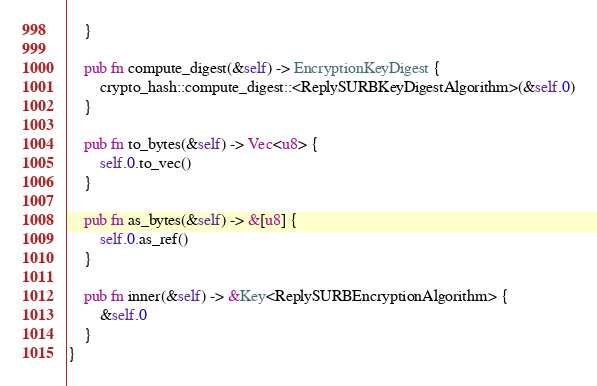Convert code to text. <code><loc_0><loc_0><loc_500><loc_500><_Rust_>    }

    pub fn compute_digest(&self) -> EncryptionKeyDigest {
        crypto_hash::compute_digest::<ReplySURBKeyDigestAlgorithm>(&self.0)
    }

    pub fn to_bytes(&self) -> Vec<u8> {
        self.0.to_vec()
    }

    pub fn as_bytes(&self) -> &[u8] {
        self.0.as_ref()
    }

    pub fn inner(&self) -> &Key<ReplySURBEncryptionAlgorithm> {
        &self.0
    }
}
</code> 